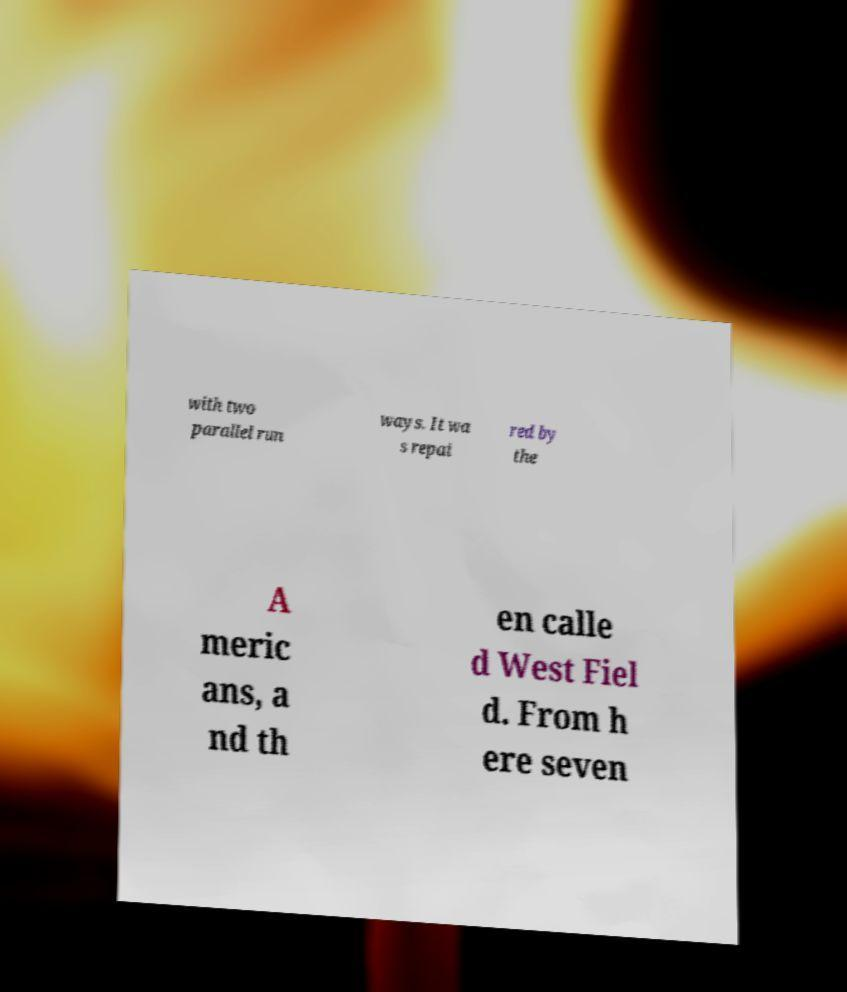Could you extract and type out the text from this image? with two parallel run ways. It wa s repai red by the A meric ans, a nd th en calle d West Fiel d. From h ere seven 